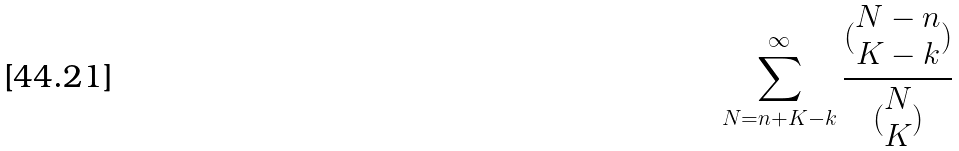<formula> <loc_0><loc_0><loc_500><loc_500>\sum _ { N = n + K - k } ^ { \infty } \frac { ( \begin{matrix} N - n \\ K - k \end{matrix} ) } { ( \begin{matrix} N \\ K \end{matrix} ) }</formula> 